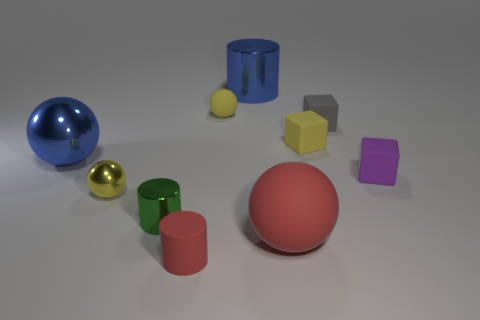Subtract all yellow metallic spheres. How many spheres are left? 3 Subtract all gray cubes. How many yellow balls are left? 2 Subtract all blue spheres. How many spheres are left? 3 Subtract all cylinders. How many objects are left? 7 Subtract 1 purple blocks. How many objects are left? 9 Subtract all brown blocks. Subtract all green cylinders. How many blocks are left? 3 Subtract all blocks. Subtract all small gray cylinders. How many objects are left? 7 Add 3 big red things. How many big red things are left? 4 Add 4 red rubber balls. How many red rubber balls exist? 5 